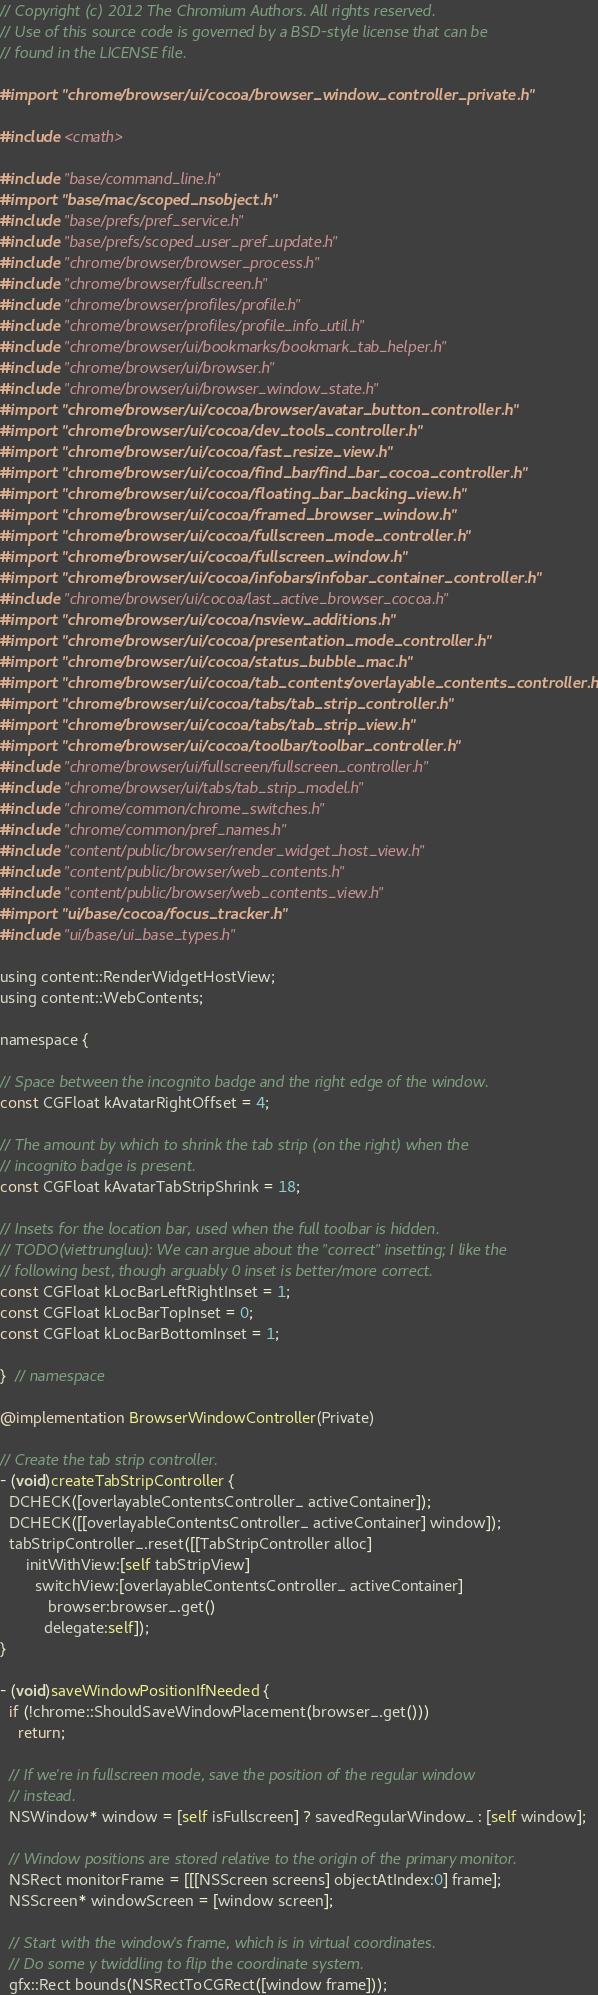Convert code to text. <code><loc_0><loc_0><loc_500><loc_500><_ObjectiveC_>// Copyright (c) 2012 The Chromium Authors. All rights reserved.
// Use of this source code is governed by a BSD-style license that can be
// found in the LICENSE file.

#import "chrome/browser/ui/cocoa/browser_window_controller_private.h"

#include <cmath>

#include "base/command_line.h"
#import "base/mac/scoped_nsobject.h"
#include "base/prefs/pref_service.h"
#include "base/prefs/scoped_user_pref_update.h"
#include "chrome/browser/browser_process.h"
#include "chrome/browser/fullscreen.h"
#include "chrome/browser/profiles/profile.h"
#include "chrome/browser/profiles/profile_info_util.h"
#include "chrome/browser/ui/bookmarks/bookmark_tab_helper.h"
#include "chrome/browser/ui/browser.h"
#include "chrome/browser/ui/browser_window_state.h"
#import "chrome/browser/ui/cocoa/browser/avatar_button_controller.h"
#import "chrome/browser/ui/cocoa/dev_tools_controller.h"
#import "chrome/browser/ui/cocoa/fast_resize_view.h"
#import "chrome/browser/ui/cocoa/find_bar/find_bar_cocoa_controller.h"
#import "chrome/browser/ui/cocoa/floating_bar_backing_view.h"
#import "chrome/browser/ui/cocoa/framed_browser_window.h"
#import "chrome/browser/ui/cocoa/fullscreen_mode_controller.h"
#import "chrome/browser/ui/cocoa/fullscreen_window.h"
#import "chrome/browser/ui/cocoa/infobars/infobar_container_controller.h"
#include "chrome/browser/ui/cocoa/last_active_browser_cocoa.h"
#import "chrome/browser/ui/cocoa/nsview_additions.h"
#import "chrome/browser/ui/cocoa/presentation_mode_controller.h"
#import "chrome/browser/ui/cocoa/status_bubble_mac.h"
#import "chrome/browser/ui/cocoa/tab_contents/overlayable_contents_controller.h"
#import "chrome/browser/ui/cocoa/tabs/tab_strip_controller.h"
#import "chrome/browser/ui/cocoa/tabs/tab_strip_view.h"
#import "chrome/browser/ui/cocoa/toolbar/toolbar_controller.h"
#include "chrome/browser/ui/fullscreen/fullscreen_controller.h"
#include "chrome/browser/ui/tabs/tab_strip_model.h"
#include "chrome/common/chrome_switches.h"
#include "chrome/common/pref_names.h"
#include "content/public/browser/render_widget_host_view.h"
#include "content/public/browser/web_contents.h"
#include "content/public/browser/web_contents_view.h"
#import "ui/base/cocoa/focus_tracker.h"
#include "ui/base/ui_base_types.h"

using content::RenderWidgetHostView;
using content::WebContents;

namespace {

// Space between the incognito badge and the right edge of the window.
const CGFloat kAvatarRightOffset = 4;

// The amount by which to shrink the tab strip (on the right) when the
// incognito badge is present.
const CGFloat kAvatarTabStripShrink = 18;

// Insets for the location bar, used when the full toolbar is hidden.
// TODO(viettrungluu): We can argue about the "correct" insetting; I like the
// following best, though arguably 0 inset is better/more correct.
const CGFloat kLocBarLeftRightInset = 1;
const CGFloat kLocBarTopInset = 0;
const CGFloat kLocBarBottomInset = 1;

}  // namespace

@implementation BrowserWindowController(Private)

// Create the tab strip controller.
- (void)createTabStripController {
  DCHECK([overlayableContentsController_ activeContainer]);
  DCHECK([[overlayableContentsController_ activeContainer] window]);
  tabStripController_.reset([[TabStripController alloc]
      initWithView:[self tabStripView]
        switchView:[overlayableContentsController_ activeContainer]
           browser:browser_.get()
          delegate:self]);
}

- (void)saveWindowPositionIfNeeded {
  if (!chrome::ShouldSaveWindowPlacement(browser_.get()))
    return;

  // If we're in fullscreen mode, save the position of the regular window
  // instead.
  NSWindow* window = [self isFullscreen] ? savedRegularWindow_ : [self window];

  // Window positions are stored relative to the origin of the primary monitor.
  NSRect monitorFrame = [[[NSScreen screens] objectAtIndex:0] frame];
  NSScreen* windowScreen = [window screen];

  // Start with the window's frame, which is in virtual coordinates.
  // Do some y twiddling to flip the coordinate system.
  gfx::Rect bounds(NSRectToCGRect([window frame]));</code> 